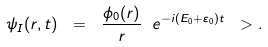Convert formula to latex. <formula><loc_0><loc_0><loc_500><loc_500>\psi _ { I } ( r , t ) \ = \ \frac { \phi _ { 0 } ( r ) } { r } \ e ^ { - i ( E _ { 0 } + \varepsilon _ { 0 } ) t } \ > .</formula> 